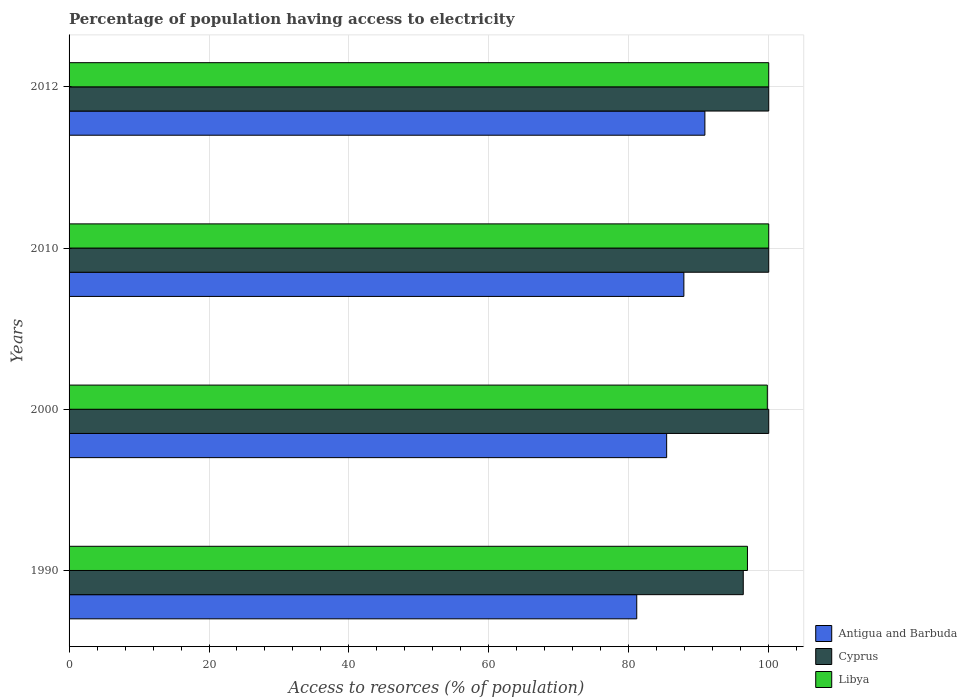How many different coloured bars are there?
Provide a short and direct response. 3. Are the number of bars per tick equal to the number of legend labels?
Keep it short and to the point. Yes. Are the number of bars on each tick of the Y-axis equal?
Your answer should be very brief. Yes. How many bars are there on the 2nd tick from the bottom?
Give a very brief answer. 3. What is the percentage of population having access to electricity in Antigua and Barbuda in 2012?
Your answer should be very brief. 90.88. Across all years, what is the minimum percentage of population having access to electricity in Libya?
Ensure brevity in your answer.  96.96. In which year was the percentage of population having access to electricity in Cyprus minimum?
Make the answer very short. 1990. What is the total percentage of population having access to electricity in Libya in the graph?
Give a very brief answer. 396.76. What is the difference between the percentage of population having access to electricity in Antigua and Barbuda in 1990 and that in 2010?
Provide a succinct answer. -6.74. What is the difference between the percentage of population having access to electricity in Cyprus in 2010 and the percentage of population having access to electricity in Antigua and Barbuda in 2012?
Offer a terse response. 9.12. What is the average percentage of population having access to electricity in Libya per year?
Ensure brevity in your answer.  99.19. In the year 2000, what is the difference between the percentage of population having access to electricity in Cyprus and percentage of population having access to electricity in Antigua and Barbuda?
Offer a terse response. 14.59. What is the ratio of the percentage of population having access to electricity in Cyprus in 1990 to that in 2000?
Offer a terse response. 0.96. Is the percentage of population having access to electricity in Antigua and Barbuda in 2000 less than that in 2010?
Give a very brief answer. Yes. Is the difference between the percentage of population having access to electricity in Cyprus in 2000 and 2012 greater than the difference between the percentage of population having access to electricity in Antigua and Barbuda in 2000 and 2012?
Make the answer very short. Yes. What is the difference between the highest and the lowest percentage of population having access to electricity in Libya?
Ensure brevity in your answer.  3.04. In how many years, is the percentage of population having access to electricity in Cyprus greater than the average percentage of population having access to electricity in Cyprus taken over all years?
Give a very brief answer. 3. What does the 3rd bar from the top in 1990 represents?
Offer a very short reply. Antigua and Barbuda. What does the 3rd bar from the bottom in 2000 represents?
Offer a very short reply. Libya. Are all the bars in the graph horizontal?
Your answer should be very brief. Yes. How many years are there in the graph?
Your answer should be very brief. 4. What is the difference between two consecutive major ticks on the X-axis?
Provide a succinct answer. 20. Are the values on the major ticks of X-axis written in scientific E-notation?
Ensure brevity in your answer.  No. Does the graph contain any zero values?
Offer a very short reply. No. Where does the legend appear in the graph?
Make the answer very short. Bottom right. How many legend labels are there?
Provide a short and direct response. 3. How are the legend labels stacked?
Provide a short and direct response. Vertical. What is the title of the graph?
Provide a short and direct response. Percentage of population having access to electricity. Does "Ecuador" appear as one of the legend labels in the graph?
Your answer should be compact. No. What is the label or title of the X-axis?
Ensure brevity in your answer.  Access to resorces (% of population). What is the Access to resorces (% of population) in Antigua and Barbuda in 1990?
Your response must be concise. 81.14. What is the Access to resorces (% of population) of Cyprus in 1990?
Offer a very short reply. 96.36. What is the Access to resorces (% of population) in Libya in 1990?
Offer a terse response. 96.96. What is the Access to resorces (% of population) in Antigua and Barbuda in 2000?
Offer a very short reply. 85.41. What is the Access to resorces (% of population) of Cyprus in 2000?
Offer a terse response. 100. What is the Access to resorces (% of population) in Libya in 2000?
Your answer should be compact. 99.8. What is the Access to resorces (% of population) of Antigua and Barbuda in 2010?
Your answer should be very brief. 87.87. What is the Access to resorces (% of population) in Cyprus in 2010?
Offer a very short reply. 100. What is the Access to resorces (% of population) in Libya in 2010?
Provide a short and direct response. 100. What is the Access to resorces (% of population) of Antigua and Barbuda in 2012?
Ensure brevity in your answer.  90.88. Across all years, what is the maximum Access to resorces (% of population) of Antigua and Barbuda?
Give a very brief answer. 90.88. Across all years, what is the minimum Access to resorces (% of population) in Antigua and Barbuda?
Ensure brevity in your answer.  81.14. Across all years, what is the minimum Access to resorces (% of population) in Cyprus?
Provide a succinct answer. 96.36. Across all years, what is the minimum Access to resorces (% of population) in Libya?
Your answer should be compact. 96.96. What is the total Access to resorces (% of population) in Antigua and Barbuda in the graph?
Keep it short and to the point. 345.3. What is the total Access to resorces (% of population) of Cyprus in the graph?
Provide a short and direct response. 396.36. What is the total Access to resorces (% of population) in Libya in the graph?
Offer a very short reply. 396.76. What is the difference between the Access to resorces (% of population) in Antigua and Barbuda in 1990 and that in 2000?
Offer a very short reply. -4.28. What is the difference between the Access to resorces (% of population) of Cyprus in 1990 and that in 2000?
Offer a terse response. -3.64. What is the difference between the Access to resorces (% of population) in Libya in 1990 and that in 2000?
Offer a terse response. -2.84. What is the difference between the Access to resorces (% of population) in Antigua and Barbuda in 1990 and that in 2010?
Provide a short and direct response. -6.74. What is the difference between the Access to resorces (% of population) of Cyprus in 1990 and that in 2010?
Keep it short and to the point. -3.64. What is the difference between the Access to resorces (% of population) in Libya in 1990 and that in 2010?
Ensure brevity in your answer.  -3.04. What is the difference between the Access to resorces (% of population) in Antigua and Barbuda in 1990 and that in 2012?
Your answer should be compact. -9.74. What is the difference between the Access to resorces (% of population) in Cyprus in 1990 and that in 2012?
Provide a short and direct response. -3.64. What is the difference between the Access to resorces (% of population) in Libya in 1990 and that in 2012?
Provide a succinct answer. -3.04. What is the difference between the Access to resorces (% of population) in Antigua and Barbuda in 2000 and that in 2010?
Offer a terse response. -2.46. What is the difference between the Access to resorces (% of population) in Cyprus in 2000 and that in 2010?
Make the answer very short. 0. What is the difference between the Access to resorces (% of population) in Antigua and Barbuda in 2000 and that in 2012?
Offer a very short reply. -5.46. What is the difference between the Access to resorces (% of population) of Antigua and Barbuda in 2010 and that in 2012?
Your answer should be compact. -3. What is the difference between the Access to resorces (% of population) in Antigua and Barbuda in 1990 and the Access to resorces (% of population) in Cyprus in 2000?
Provide a short and direct response. -18.86. What is the difference between the Access to resorces (% of population) in Antigua and Barbuda in 1990 and the Access to resorces (% of population) in Libya in 2000?
Provide a short and direct response. -18.66. What is the difference between the Access to resorces (% of population) of Cyprus in 1990 and the Access to resorces (% of population) of Libya in 2000?
Your answer should be compact. -3.44. What is the difference between the Access to resorces (% of population) of Antigua and Barbuda in 1990 and the Access to resorces (% of population) of Cyprus in 2010?
Offer a terse response. -18.86. What is the difference between the Access to resorces (% of population) in Antigua and Barbuda in 1990 and the Access to resorces (% of population) in Libya in 2010?
Offer a very short reply. -18.86. What is the difference between the Access to resorces (% of population) in Cyprus in 1990 and the Access to resorces (% of population) in Libya in 2010?
Your answer should be very brief. -3.64. What is the difference between the Access to resorces (% of population) in Antigua and Barbuda in 1990 and the Access to resorces (% of population) in Cyprus in 2012?
Offer a terse response. -18.86. What is the difference between the Access to resorces (% of population) in Antigua and Barbuda in 1990 and the Access to resorces (% of population) in Libya in 2012?
Provide a succinct answer. -18.86. What is the difference between the Access to resorces (% of population) in Cyprus in 1990 and the Access to resorces (% of population) in Libya in 2012?
Offer a very short reply. -3.64. What is the difference between the Access to resorces (% of population) of Antigua and Barbuda in 2000 and the Access to resorces (% of population) of Cyprus in 2010?
Provide a succinct answer. -14.59. What is the difference between the Access to resorces (% of population) in Antigua and Barbuda in 2000 and the Access to resorces (% of population) in Libya in 2010?
Ensure brevity in your answer.  -14.59. What is the difference between the Access to resorces (% of population) of Cyprus in 2000 and the Access to resorces (% of population) of Libya in 2010?
Make the answer very short. 0. What is the difference between the Access to resorces (% of population) of Antigua and Barbuda in 2000 and the Access to resorces (% of population) of Cyprus in 2012?
Offer a very short reply. -14.59. What is the difference between the Access to resorces (% of population) of Antigua and Barbuda in 2000 and the Access to resorces (% of population) of Libya in 2012?
Your answer should be very brief. -14.59. What is the difference between the Access to resorces (% of population) of Cyprus in 2000 and the Access to resorces (% of population) of Libya in 2012?
Keep it short and to the point. 0. What is the difference between the Access to resorces (% of population) of Antigua and Barbuda in 2010 and the Access to resorces (% of population) of Cyprus in 2012?
Your answer should be very brief. -12.13. What is the difference between the Access to resorces (% of population) in Antigua and Barbuda in 2010 and the Access to resorces (% of population) in Libya in 2012?
Provide a short and direct response. -12.13. What is the difference between the Access to resorces (% of population) of Cyprus in 2010 and the Access to resorces (% of population) of Libya in 2012?
Provide a succinct answer. 0. What is the average Access to resorces (% of population) in Antigua and Barbuda per year?
Offer a terse response. 86.32. What is the average Access to resorces (% of population) of Cyprus per year?
Provide a succinct answer. 99.09. What is the average Access to resorces (% of population) in Libya per year?
Offer a terse response. 99.19. In the year 1990, what is the difference between the Access to resorces (% of population) of Antigua and Barbuda and Access to resorces (% of population) of Cyprus?
Give a very brief answer. -15.23. In the year 1990, what is the difference between the Access to resorces (% of population) in Antigua and Barbuda and Access to resorces (% of population) in Libya?
Your response must be concise. -15.82. In the year 1990, what is the difference between the Access to resorces (% of population) in Cyprus and Access to resorces (% of population) in Libya?
Provide a succinct answer. -0.6. In the year 2000, what is the difference between the Access to resorces (% of population) in Antigua and Barbuda and Access to resorces (% of population) in Cyprus?
Your answer should be very brief. -14.59. In the year 2000, what is the difference between the Access to resorces (% of population) of Antigua and Barbuda and Access to resorces (% of population) of Libya?
Ensure brevity in your answer.  -14.39. In the year 2010, what is the difference between the Access to resorces (% of population) of Antigua and Barbuda and Access to resorces (% of population) of Cyprus?
Offer a very short reply. -12.13. In the year 2010, what is the difference between the Access to resorces (% of population) of Antigua and Barbuda and Access to resorces (% of population) of Libya?
Provide a short and direct response. -12.13. In the year 2012, what is the difference between the Access to resorces (% of population) in Antigua and Barbuda and Access to resorces (% of population) in Cyprus?
Your answer should be compact. -9.12. In the year 2012, what is the difference between the Access to resorces (% of population) of Antigua and Barbuda and Access to resorces (% of population) of Libya?
Ensure brevity in your answer.  -9.12. What is the ratio of the Access to resorces (% of population) in Antigua and Barbuda in 1990 to that in 2000?
Ensure brevity in your answer.  0.95. What is the ratio of the Access to resorces (% of population) of Cyprus in 1990 to that in 2000?
Make the answer very short. 0.96. What is the ratio of the Access to resorces (% of population) of Libya in 1990 to that in 2000?
Offer a very short reply. 0.97. What is the ratio of the Access to resorces (% of population) of Antigua and Barbuda in 1990 to that in 2010?
Provide a short and direct response. 0.92. What is the ratio of the Access to resorces (% of population) of Cyprus in 1990 to that in 2010?
Provide a short and direct response. 0.96. What is the ratio of the Access to resorces (% of population) of Libya in 1990 to that in 2010?
Offer a very short reply. 0.97. What is the ratio of the Access to resorces (% of population) in Antigua and Barbuda in 1990 to that in 2012?
Provide a short and direct response. 0.89. What is the ratio of the Access to resorces (% of population) in Cyprus in 1990 to that in 2012?
Your answer should be very brief. 0.96. What is the ratio of the Access to resorces (% of population) in Libya in 1990 to that in 2012?
Ensure brevity in your answer.  0.97. What is the ratio of the Access to resorces (% of population) in Antigua and Barbuda in 2000 to that in 2010?
Your answer should be very brief. 0.97. What is the ratio of the Access to resorces (% of population) of Antigua and Barbuda in 2000 to that in 2012?
Your answer should be very brief. 0.94. What is the ratio of the Access to resorces (% of population) of Libya in 2000 to that in 2012?
Your response must be concise. 1. What is the difference between the highest and the second highest Access to resorces (% of population) in Antigua and Barbuda?
Provide a succinct answer. 3. What is the difference between the highest and the lowest Access to resorces (% of population) of Antigua and Barbuda?
Provide a short and direct response. 9.74. What is the difference between the highest and the lowest Access to resorces (% of population) of Cyprus?
Provide a succinct answer. 3.64. What is the difference between the highest and the lowest Access to resorces (% of population) in Libya?
Your response must be concise. 3.04. 